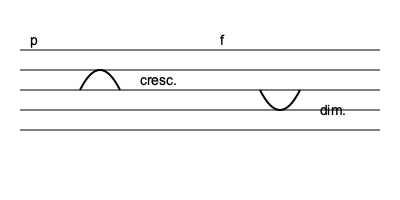In this musical score excerpt, what is the expected dynamic level at the end of the phrase, considering the initial piano marking and subsequent dynamic instructions? To determine the expected dynamic level at the end of the phrase, we need to follow the dynamic markings step-by-step:

1. The phrase begins with a "p" (piano) marking, indicating a soft dynamic level.

2. Following the initial "p", there is a crescendo marking (indicated by the hairpin opening to the right). This instructs the performer to gradually increase the volume.

3. The crescendo leads to an "f" (forte) marking, signifying a loud dynamic level.

4. After the forte, there is a diminuendo marking (indicated by the hairpin closing to the right). This instructs the performer to gradually decrease the volume.

5. The diminuendo is not followed by any specific dynamic marking at the end of the phrase.

Given this sequence, we can deduce that the final dynamic level should be softer than forte but not as soft as the initial piano. In classical music performance practice, when a diminuendo is not followed by a specific dynamic marking, it's generally interpreted as a return to the previous dynamic level before the last change.

Therefore, the expected dynamic level at the end of the phrase would be piano (p), the same as the initial marking.
Answer: Piano (p) 